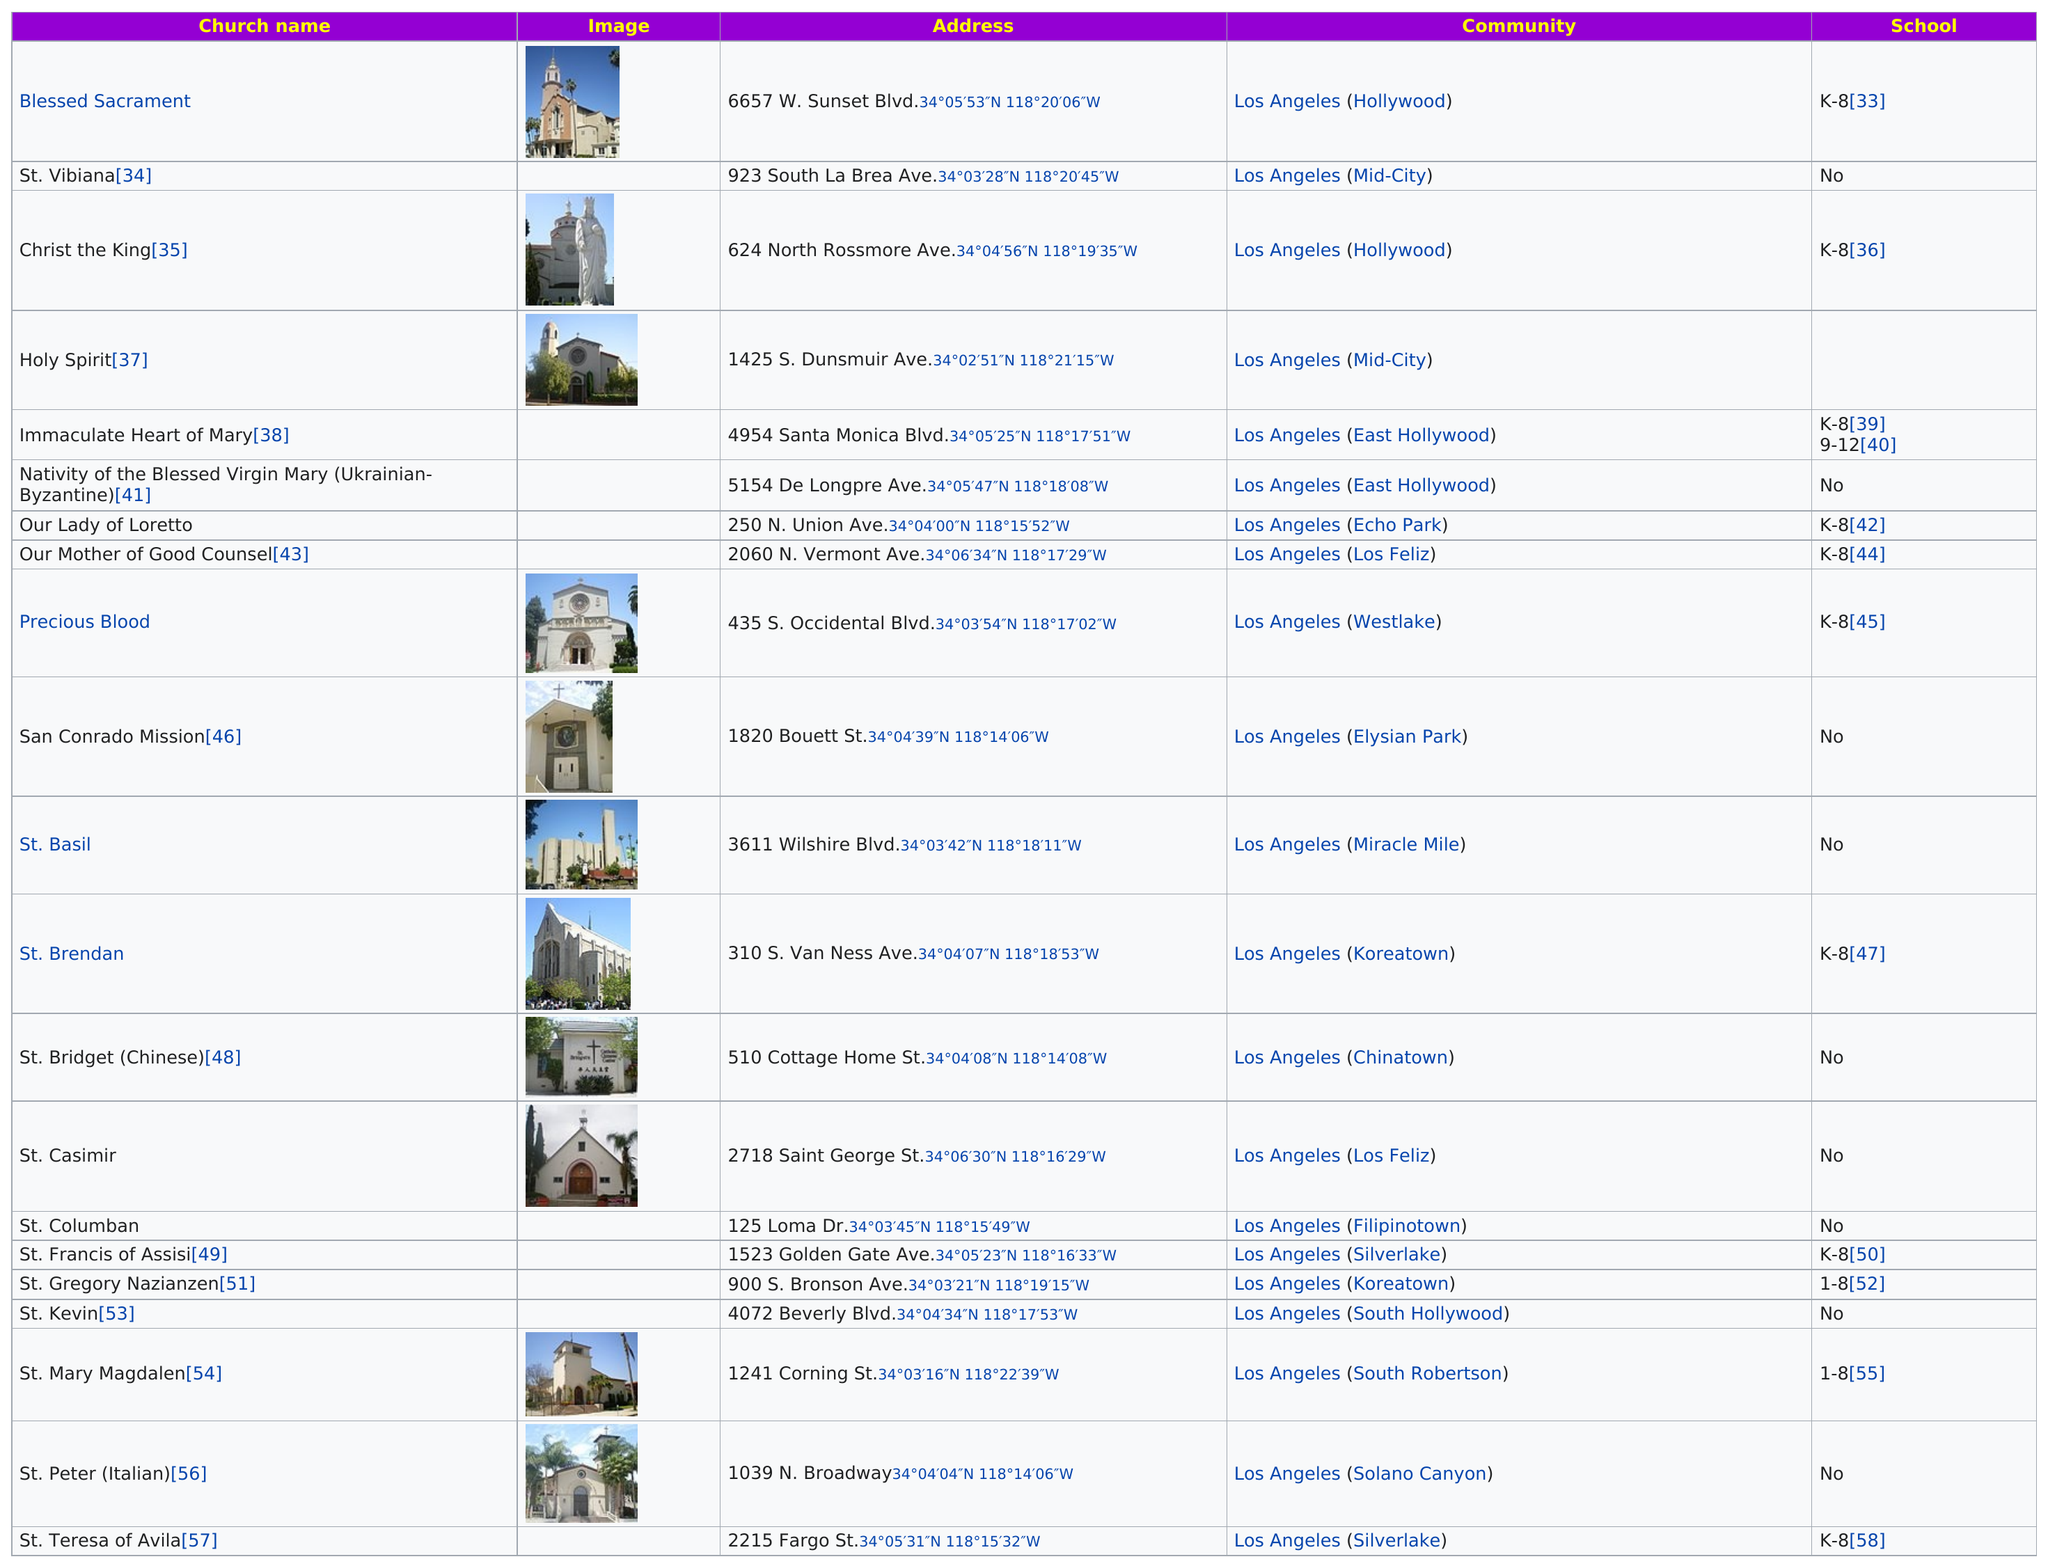Mention a couple of crucial points in this snapshot. There are 11 churches that have schools. The last church located in Koreatown is St. Gregory Nazianzen. Immaculate Heart of Mary school offers the most grades. There are 12 churches named after saints. Our lady of Loretto is listed below the Holy Spirit in the table. 